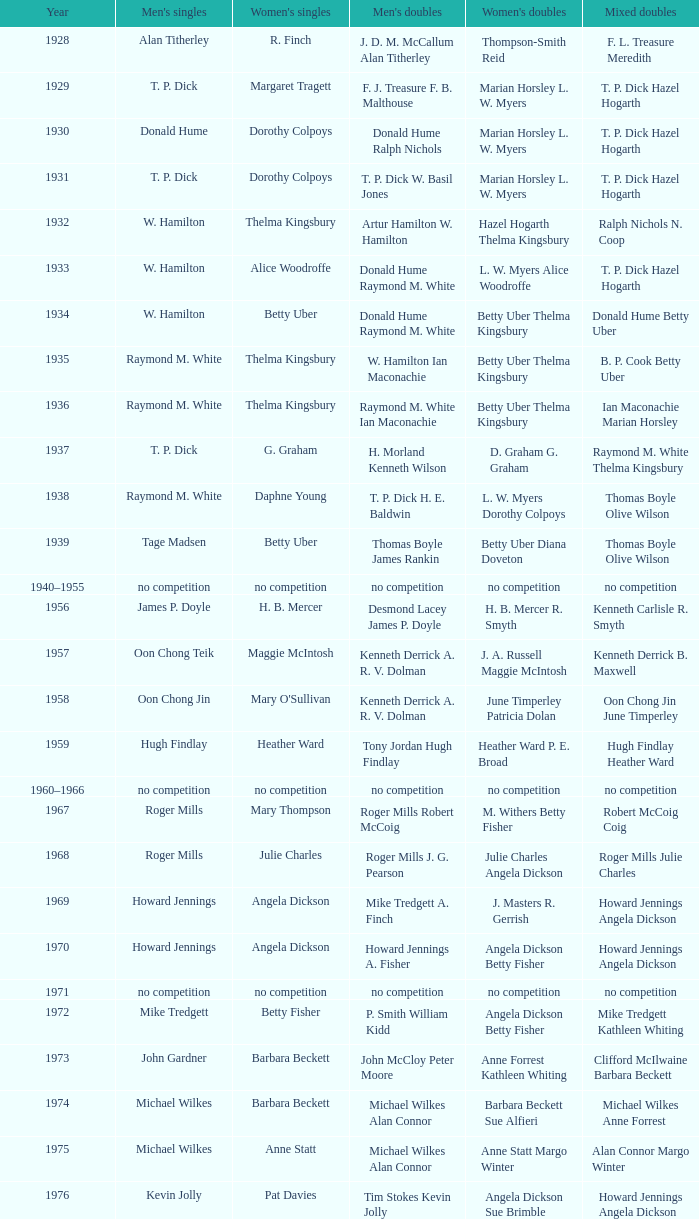Who emerged victorious in the women's singles, during the year raymond m. white secured the men's singles and w. hamilton ian maconachie clinched the men's doubles? Thelma Kingsbury. 